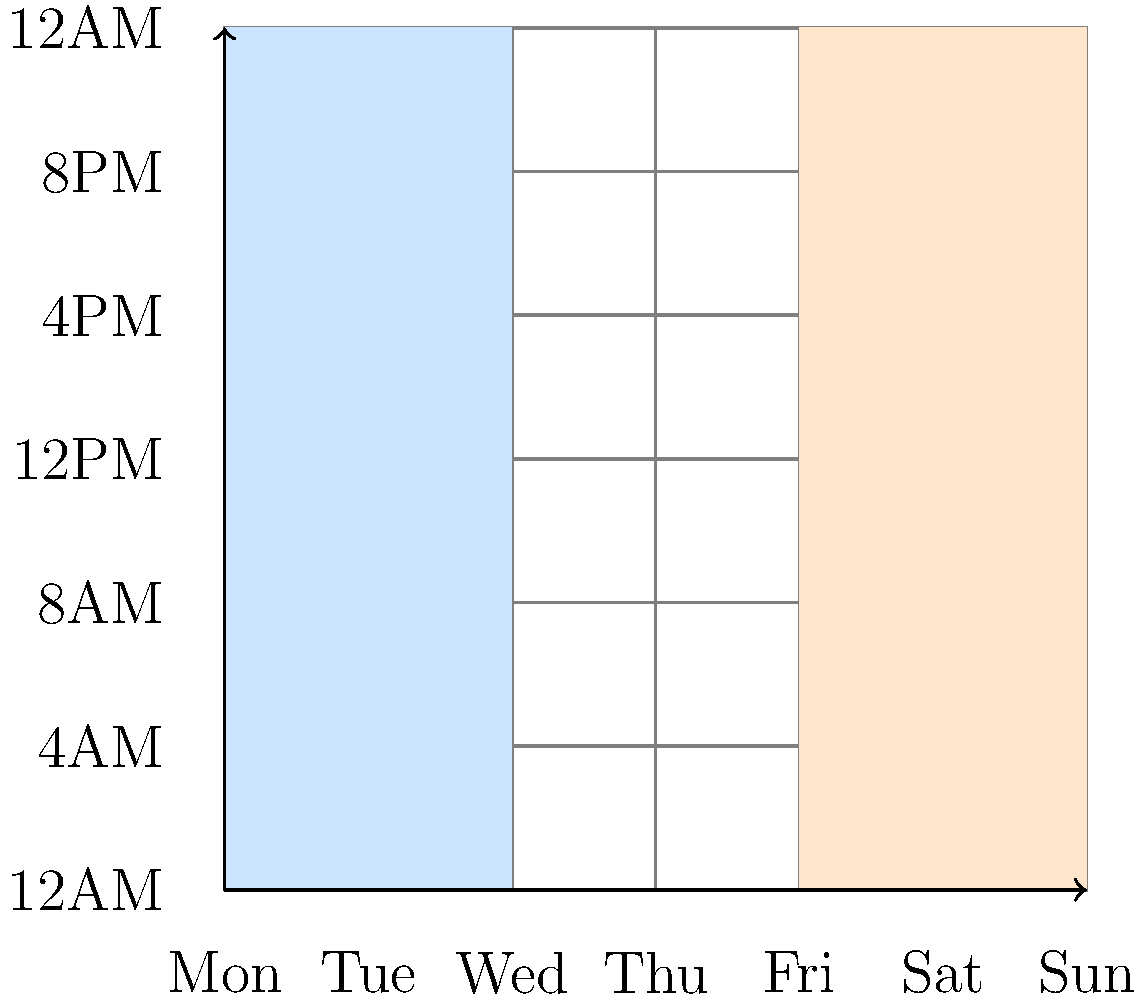As a divorce attorney, you're helping a client visualize their child custody schedule. The graph represents a weekly calendar, with days on the x-axis and hours on the y-axis. Blue shading indicates time with Parent A, and orange shading indicates time with Parent B. Based on the graph, how many full days per week does the child spend with Parent A? To determine the number of full days the child spends with Parent A, we need to analyze the blue shaded areas in the graph:

1. The blue shading covers Monday and Tuesday completely (2 full days).
2. There are no other full days covered by blue shading.
3. The remaining blue shaded areas are partial days (Wednesday).
4. We are only counting full days in this question.

Therefore, the child spends 2 full days per week with Parent A.

It's worth noting that:
- Parent B has full custody on Friday, Saturday, and Sunday (3 full days, shown in orange).
- Wednesday and Thursday appear to have split custody, but we're not considering partial days for this question.

As a divorce attorney, understanding this visual representation is crucial for explaining custody arrangements to clients and ensuring they comprehend the time allocation between parents.
Answer: 2 days 